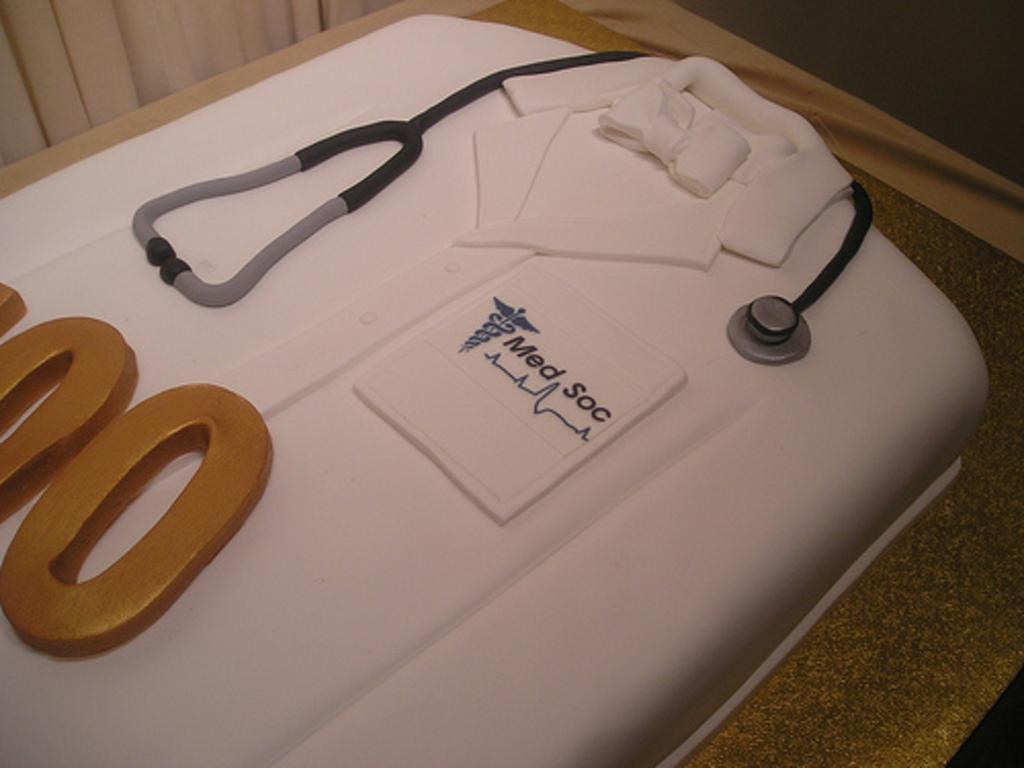What is the shape of the cake in the image? The cake in the image is in the shape of an apron and stethoscope. What else can be seen in the image besides the cake? There are curtains visible in the image. How many cherries are on the cake in the image? There is no mention of cherries on the cake in the image, so we cannot determine their number. 